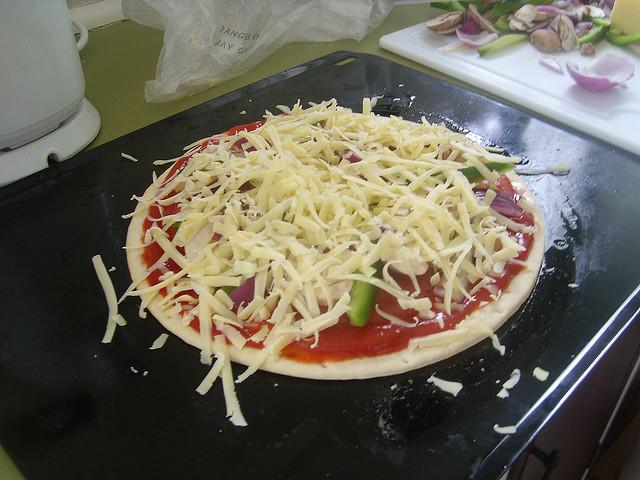What is the green vegetable on the pizza?
Concise answer only. Pepper. Is this pizza ready to eat?
Be succinct. No. Is this a homemade pizza or store-bought?
Be succinct. Homemade. Is there pasta in the photo?
Quick response, please. No. 